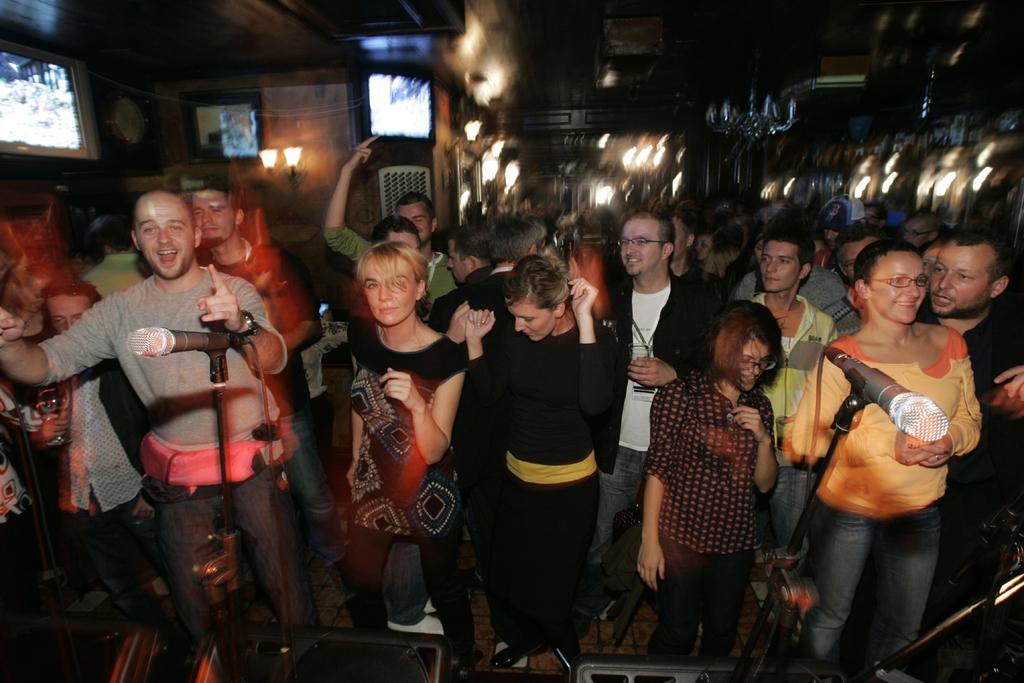In one or two sentences, can you explain what this image depicts? In this picture we can see two mics and a group of people standing on the floor and in the background we can see lights, screens and it is blurry. 